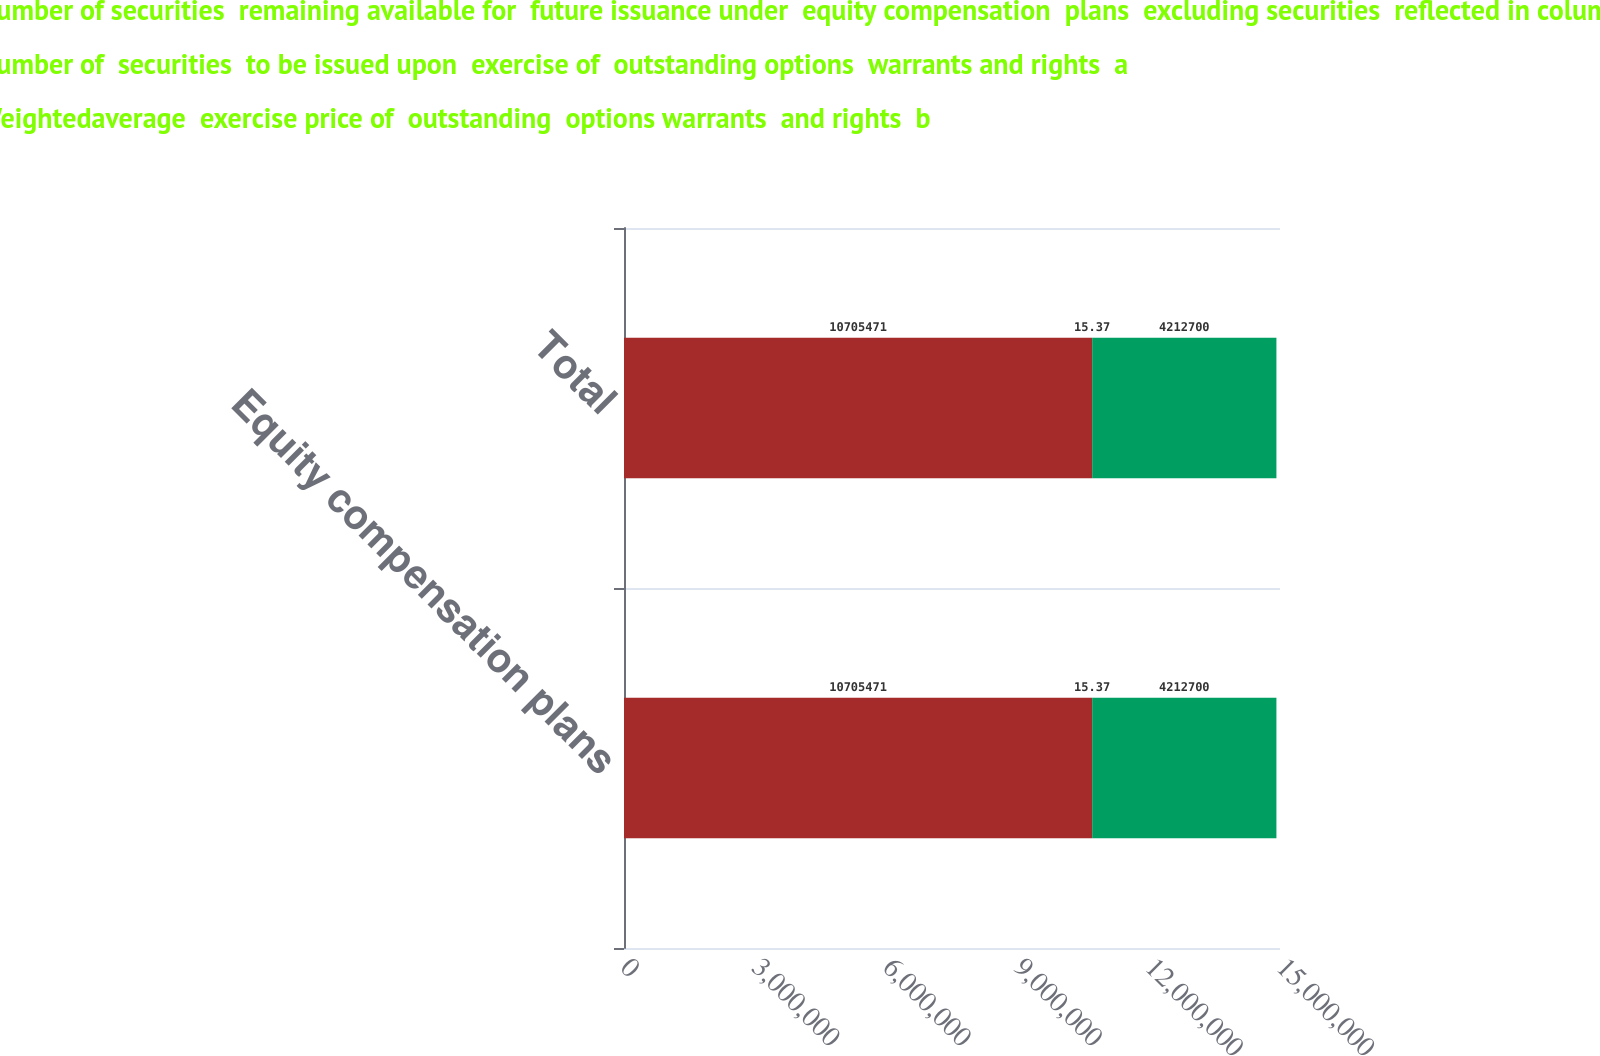Convert chart to OTSL. <chart><loc_0><loc_0><loc_500><loc_500><stacked_bar_chart><ecel><fcel>Equity compensation plans<fcel>Total<nl><fcel>Number of securities  remaining available for  future issuance under  equity compensation  plans  excluding securities  reflected in column a  c<fcel>1.07055e+07<fcel>1.07055e+07<nl><fcel>Number of  securities  to be issued upon  exercise of  outstanding options  warrants and rights  a<fcel>15.37<fcel>15.37<nl><fcel>Weightedaverage  exercise price of  outstanding  options warrants  and rights  b<fcel>4.2127e+06<fcel>4.2127e+06<nl></chart> 